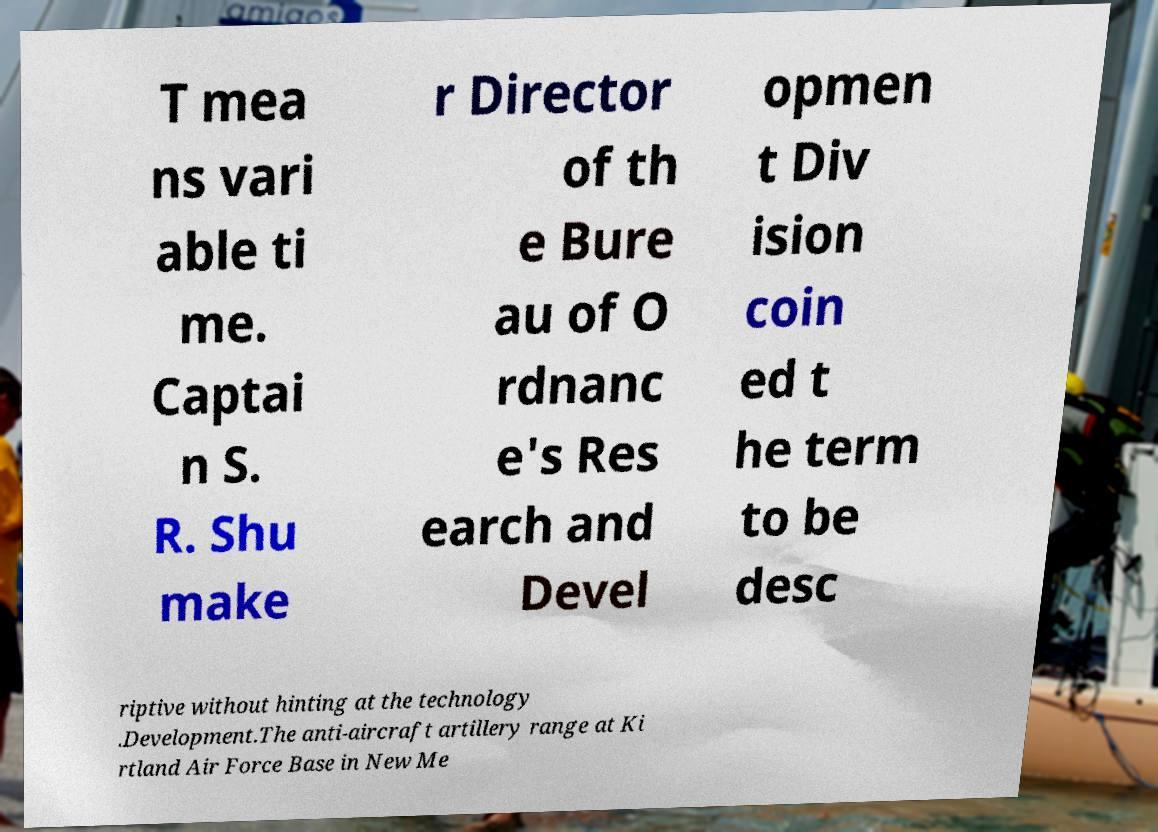There's text embedded in this image that I need extracted. Can you transcribe it verbatim? T mea ns vari able ti me. Captai n S. R. Shu make r Director of th e Bure au of O rdnanc e's Res earch and Devel opmen t Div ision coin ed t he term to be desc riptive without hinting at the technology .Development.The anti-aircraft artillery range at Ki rtland Air Force Base in New Me 